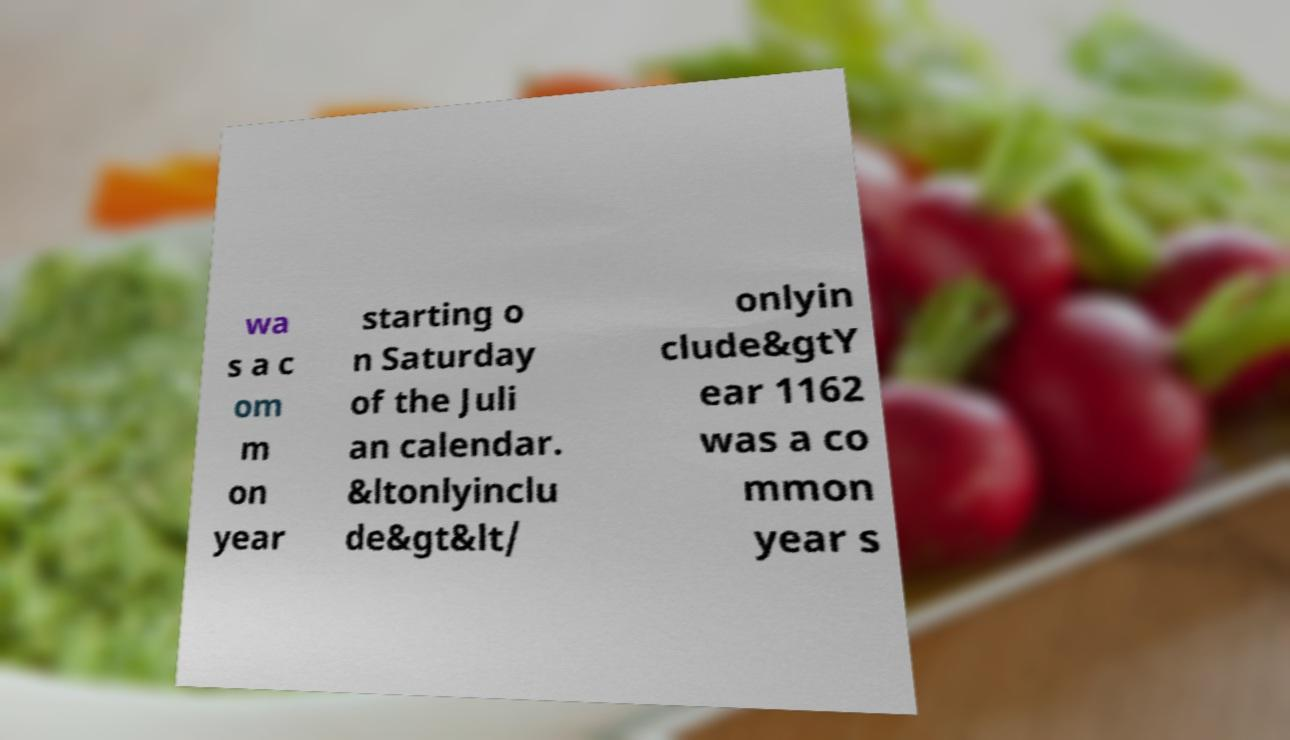Could you extract and type out the text from this image? wa s a c om m on year starting o n Saturday of the Juli an calendar. &ltonlyinclu de&gt&lt/ onlyin clude&gtY ear 1162 was a co mmon year s 